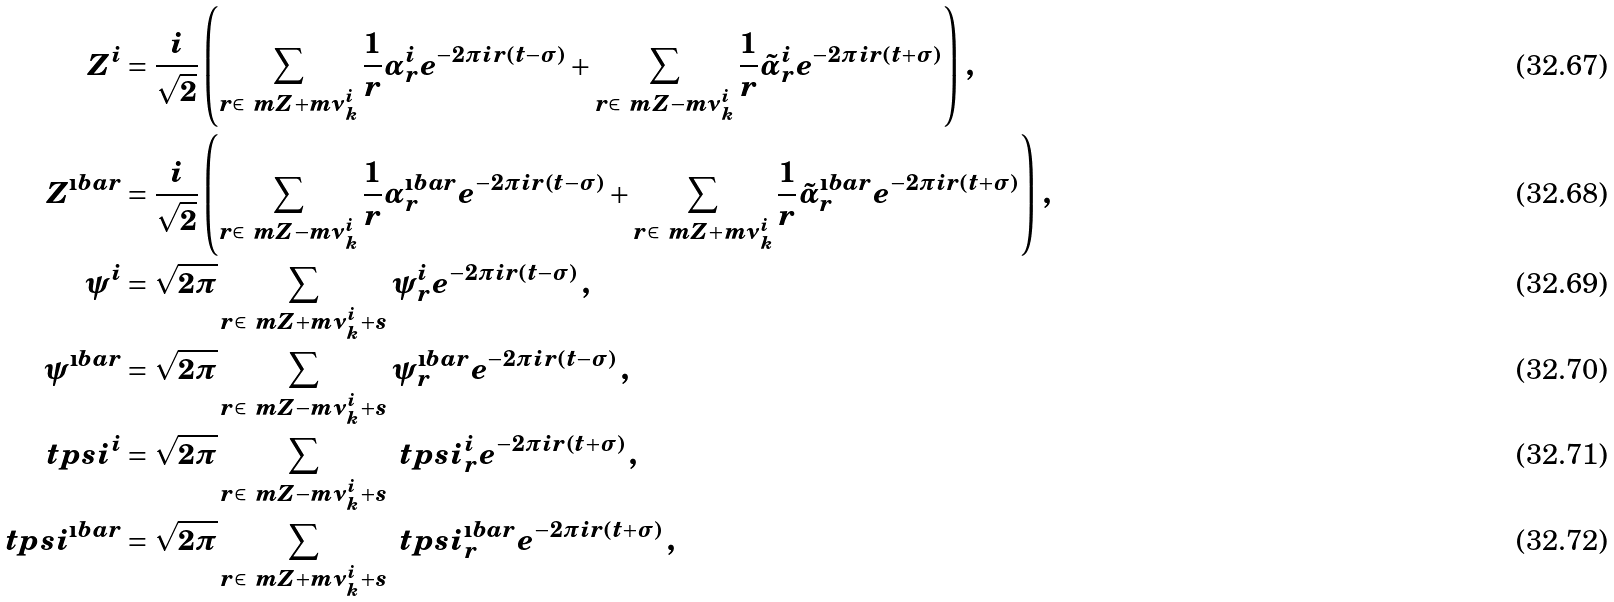Convert formula to latex. <formula><loc_0><loc_0><loc_500><loc_500>Z ^ { i } & = \frac { i } { \sqrt { 2 } } \left ( \sum _ { r \in \ m Z + m \nu _ { k } ^ { i } } \frac { 1 } { r } \alpha ^ { i } _ { r } e ^ { - 2 \pi i r ( t - \sigma ) } + \sum _ { r \in \ m Z - m \nu _ { k } ^ { i } } \frac { 1 } { r } \tilde { \alpha } ^ { i } _ { r } e ^ { - 2 \pi i r ( t + \sigma ) } \right ) \, , \\ Z ^ { \i b a r } & = \frac { i } { \sqrt { 2 } } \left ( \sum _ { r \in \ m Z - m \nu _ { k } ^ { i } } \frac { 1 } { r } \alpha ^ { \i b a r } _ { r } e ^ { - 2 \pi i r ( t - \sigma ) } + \sum _ { r \in \ m Z + m \nu _ { k } ^ { i } } \frac { 1 } { r } \tilde { \alpha } ^ { \i b a r } _ { r } e ^ { - 2 \pi i r ( t + \sigma ) } \right ) \, , \\ \psi ^ { i } & = \sqrt { 2 \pi } \sum _ { r \in \ m Z + m \nu _ { k } ^ { i } + s } \psi ^ { i } _ { r } e ^ { - 2 \pi i r ( t - \sigma ) } \, , \\ \psi ^ { \i b a r } & = \sqrt { 2 \pi } \sum _ { r \in \ m Z - m \nu _ { k } ^ { i } + s } \psi ^ { \i b a r } _ { r } e ^ { - 2 \pi i r ( t - \sigma ) } \, , \\ \ t p s i ^ { i } & = \sqrt { 2 \pi } \sum _ { r \in \ m Z - m \nu _ { k } ^ { i } + s } \ t p s i ^ { i } _ { r } e ^ { - 2 \pi i r ( t + \sigma ) } \, , \\ \ t p s i ^ { \i b a r } & = \sqrt { 2 \pi } \sum _ { r \in \ m Z + m \nu _ { k } ^ { i } + s } \ t p s i ^ { \i b a r } _ { r } e ^ { - 2 \pi i r ( t + \sigma ) } \, ,</formula> 